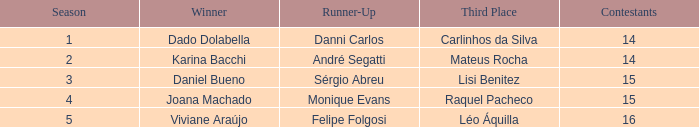When the victory went to karina bacchi, who ended up in third place? Mateus Rocha. Parse the full table. {'header': ['Season', 'Winner', 'Runner-Up', 'Third Place', 'Contestants'], 'rows': [['1', 'Dado Dolabella', 'Danni Carlos', 'Carlinhos da Silva', '14'], ['2', 'Karina Bacchi', 'André Segatti', 'Mateus Rocha', '14'], ['3', 'Daniel Bueno', 'Sérgio Abreu', 'Lisi Benitez', '15'], ['4', 'Joana Machado', 'Monique Evans', 'Raquel Pacheco', '15'], ['5', 'Viviane Araújo', 'Felipe Folgosi', 'Léo Áquilla', '16']]} 